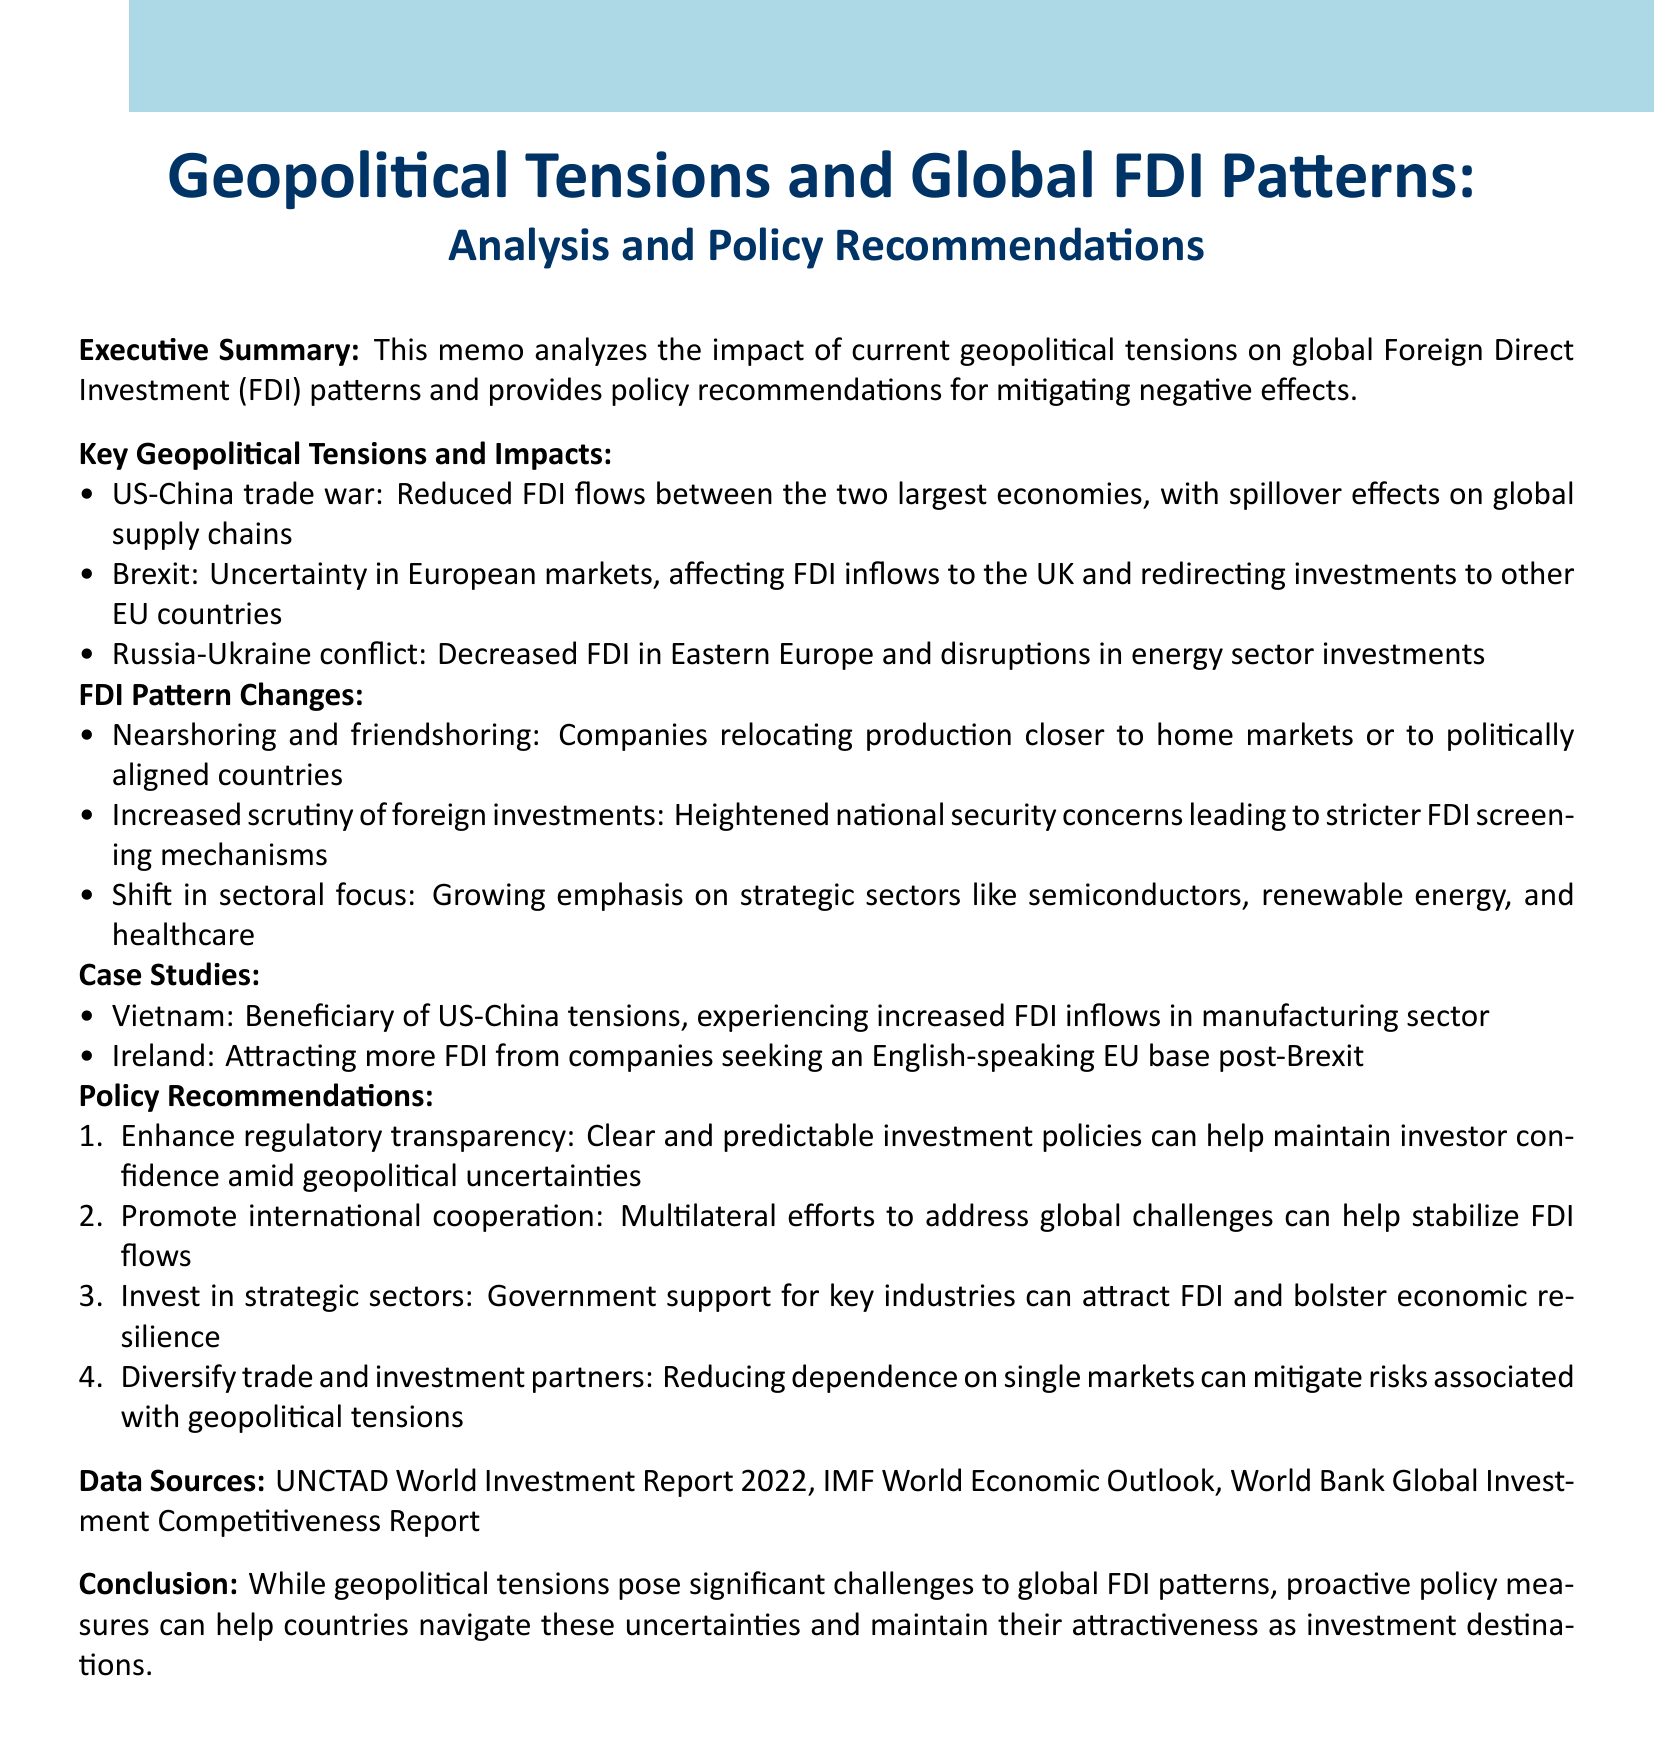what is the title of the memo? The title of the memo is stated at the top of the document, highlighting its focus on geopolitical tensions and FDI patterns.
Answer: Geopolitical Tensions and Global FDI Patterns: Analysis and Policy Recommendations how many key geopolitical tensions are identified? The document lists three specific geopolitical tensions in the section dedicated to them.
Answer: Three what is one impact of the US-China trade war? The impact of the US-China trade war is detailed in the memo under key tensions, specifically mentioning reduced FDI flows.
Answer: Reduced FDI flows which country is mentioned as benefitting from US-China tensions? The memo includes a case study that specifically discusses Vietnam's increased FDI inflows due to US-China tensions.
Answer: Vietnam what is one policy recommendation made in the memo? The document provides several policy recommendations but only requires one as the answer, which can be easily identified.
Answer: Enhance regulatory transparency which strategic sectors are highlighted as a shift in focus for FDI? The memo mentions a shift in sectoral focus towards specific sectors, indicating why they are important in the current geopolitical context.
Answer: Semiconductors, renewable energy, and healthcare what type of FDI pattern involves relocating production closer to home markets? The document describes a trend in FDI patterns as nearshoring, especially pertinent in the current geopolitical climate.
Answer: Nearshoring how does the memo suggest diversifying trade partners? This recommendation is aimed at mitigating risks associated with geopolitical tensions and is summarized in a concise way in the document.
Answer: Reducing dependence on single markets 